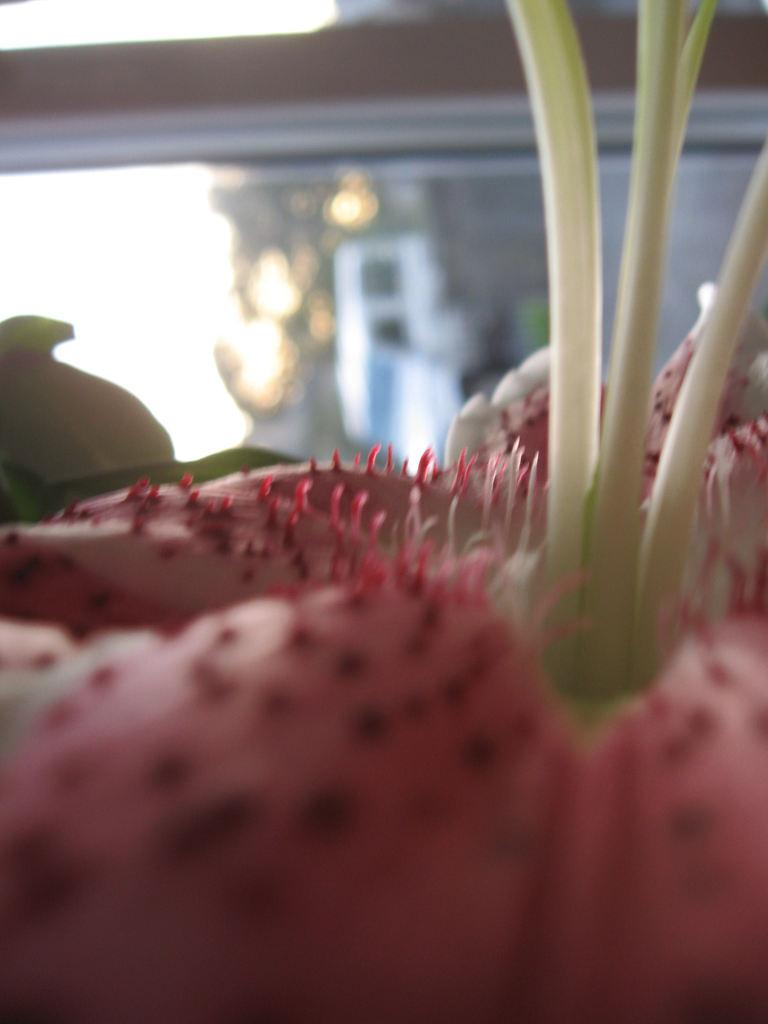What is the main subject in the foreground of the image? There is an object in the foreground of the image. Can you describe the color of the object? The object is pink in color. What can be seen in the background of the image? There is a glass in the background of the image. What type of approval is required to open the jar in the image? There is no jar present in the image, so approval is not required for any jar-related activity. 